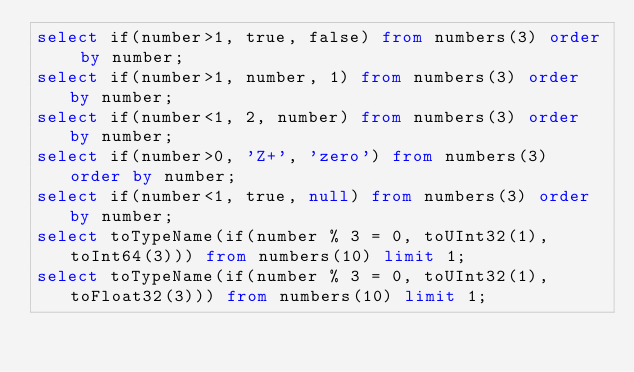Convert code to text. <code><loc_0><loc_0><loc_500><loc_500><_SQL_>select if(number>1, true, false) from numbers(3) order by number;
select if(number>1, number, 1) from numbers(3) order by number;
select if(number<1, 2, number) from numbers(3) order by number;
select if(number>0, 'Z+', 'zero') from numbers(3) order by number;
select if(number<1, true, null) from numbers(3) order by number;
select toTypeName(if(number % 3 = 0, toUInt32(1), toInt64(3))) from numbers(10) limit 1;
select toTypeName(if(number % 3 = 0, toUInt32(1), toFloat32(3))) from numbers(10) limit 1;
</code> 